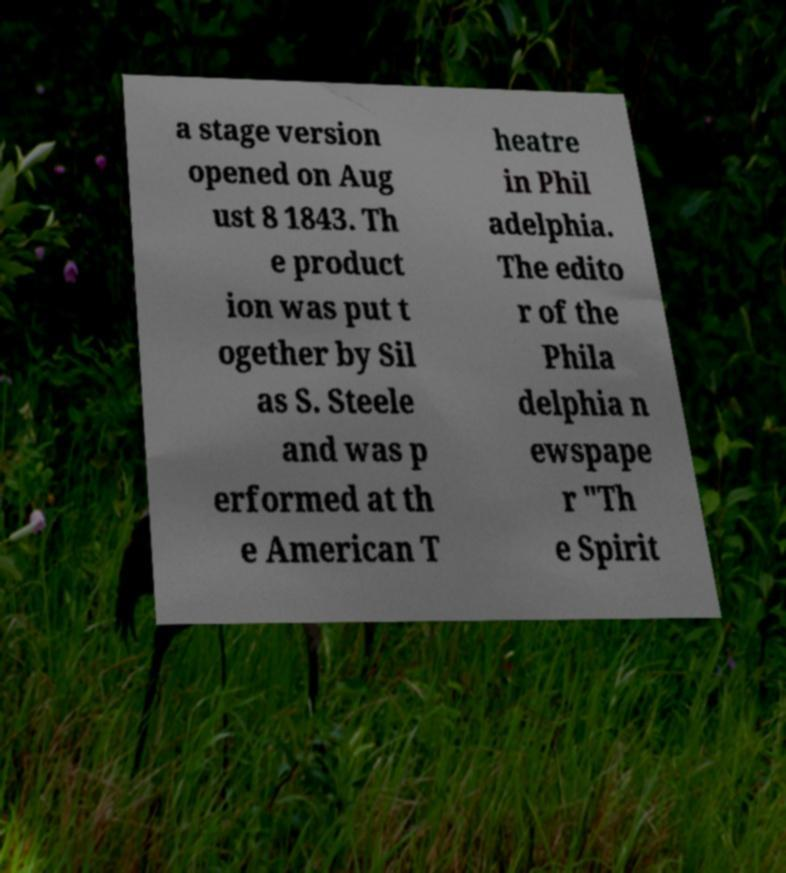Please identify and transcribe the text found in this image. a stage version opened on Aug ust 8 1843. Th e product ion was put t ogether by Sil as S. Steele and was p erformed at th e American T heatre in Phil adelphia. The edito r of the Phila delphia n ewspape r "Th e Spirit 